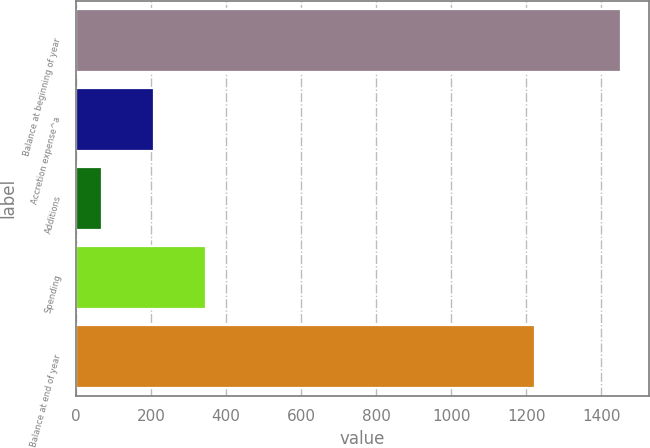Convert chart to OTSL. <chart><loc_0><loc_0><loc_500><loc_500><bar_chart><fcel>Balance at beginning of year<fcel>Accretion expense^a<fcel>Additions<fcel>Spending<fcel>Balance at end of year<nl><fcel>1453<fcel>208.3<fcel>70<fcel>346.6<fcel>1222<nl></chart> 